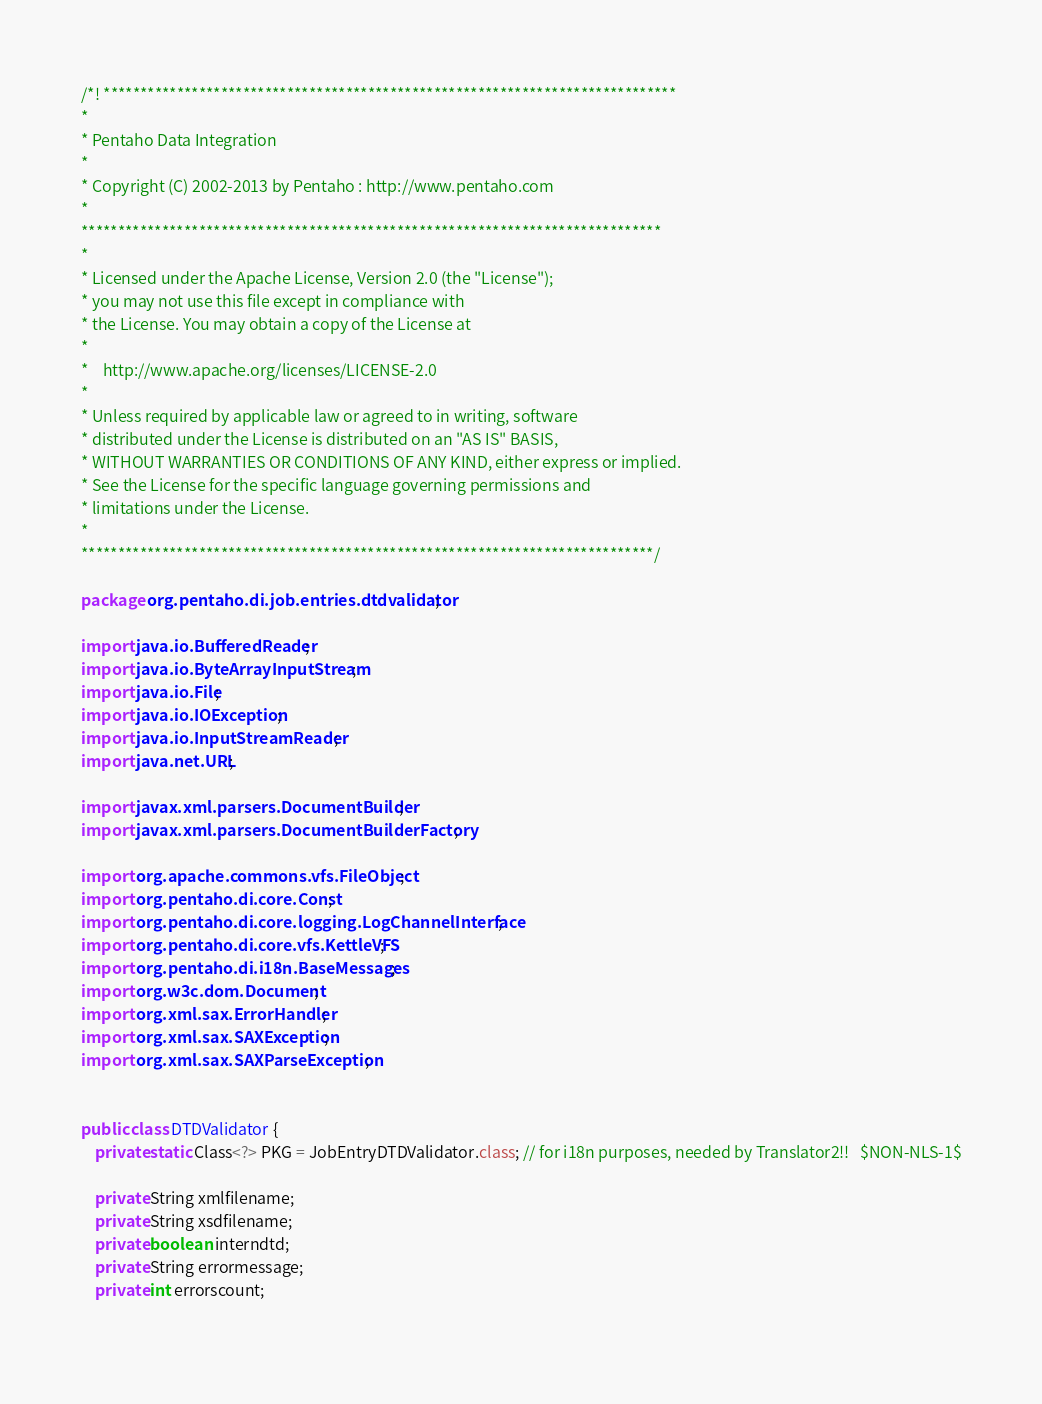<code> <loc_0><loc_0><loc_500><loc_500><_Java_>/*! ******************************************************************************
*
* Pentaho Data Integration
*
* Copyright (C) 2002-2013 by Pentaho : http://www.pentaho.com
*
*******************************************************************************
*
* Licensed under the Apache License, Version 2.0 (the "License");
* you may not use this file except in compliance with
* the License. You may obtain a copy of the License at
*
*    http://www.apache.org/licenses/LICENSE-2.0
*
* Unless required by applicable law or agreed to in writing, software
* distributed under the License is distributed on an "AS IS" BASIS,
* WITHOUT WARRANTIES OR CONDITIONS OF ANY KIND, either express or implied.
* See the License for the specific language governing permissions and
* limitations under the License.
*
******************************************************************************/

package org.pentaho.di.job.entries.dtdvalidator;

import java.io.BufferedReader;
import java.io.ByteArrayInputStream;
import java.io.File;
import java.io.IOException;
import java.io.InputStreamReader;
import java.net.URL;

import javax.xml.parsers.DocumentBuilder;
import javax.xml.parsers.DocumentBuilderFactory;

import org.apache.commons.vfs.FileObject;
import org.pentaho.di.core.Const;
import org.pentaho.di.core.logging.LogChannelInterface;
import org.pentaho.di.core.vfs.KettleVFS;
import org.pentaho.di.i18n.BaseMessages;
import org.w3c.dom.Document;
import org.xml.sax.ErrorHandler;
import org.xml.sax.SAXException;
import org.xml.sax.SAXParseException;


public class DTDValidator {
	private static Class<?> PKG = JobEntryDTDValidator.class; // for i18n purposes, needed by Translator2!!   $NON-NLS-1$

	private String xmlfilename;
	private String xsdfilename;
	private boolean interndtd;
	private String errormessage;
	private int errorscount;
	</code> 